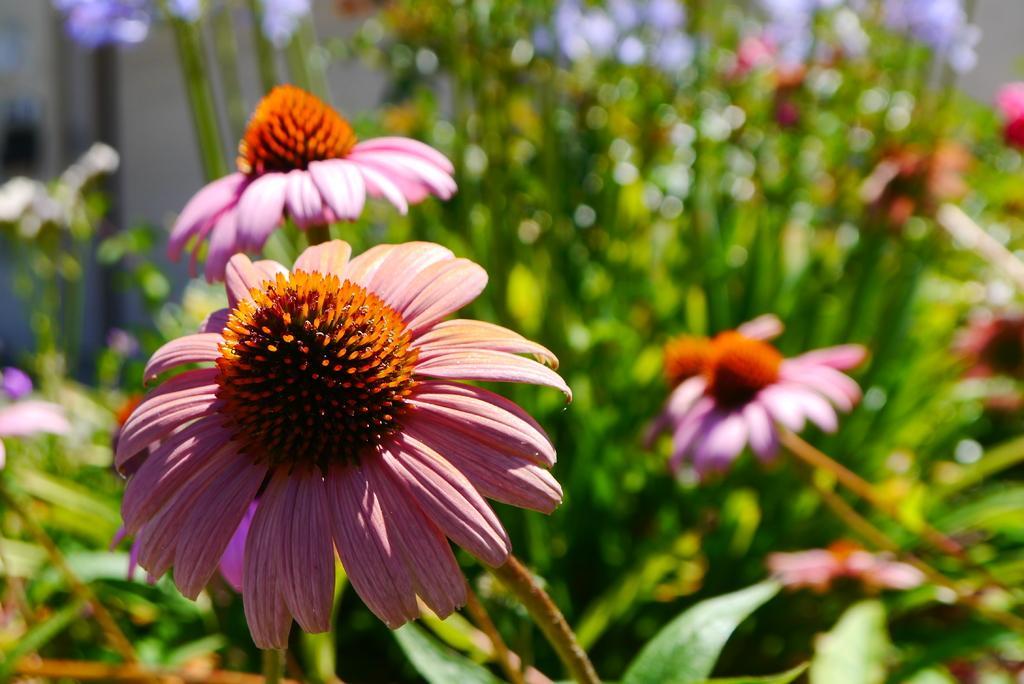In one or two sentences, can you explain what this image depicts? In this image I can see floral plants. The background is blurred. 